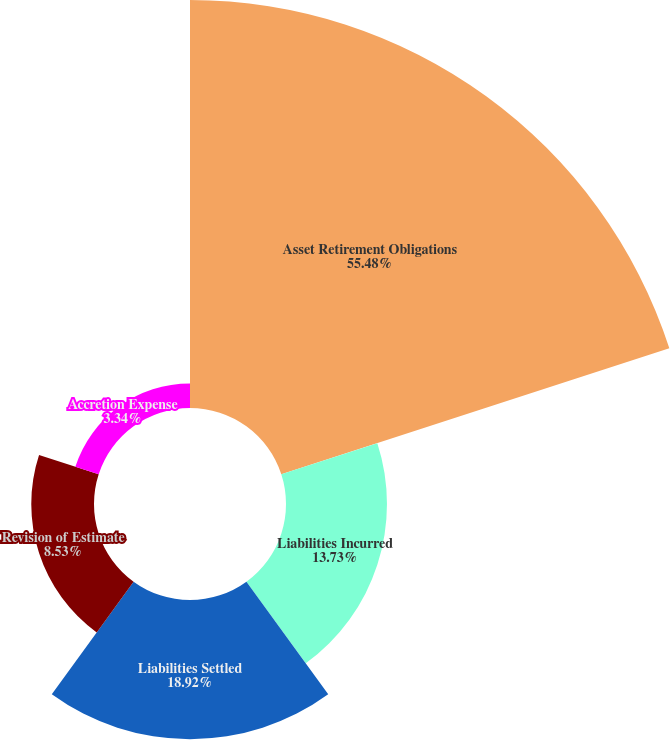<chart> <loc_0><loc_0><loc_500><loc_500><pie_chart><fcel>Asset Retirement Obligations<fcel>Liabilities Incurred<fcel>Liabilities Settled<fcel>Revision of Estimate<fcel>Accretion Expense<nl><fcel>55.48%<fcel>13.73%<fcel>18.92%<fcel>8.53%<fcel>3.34%<nl></chart> 